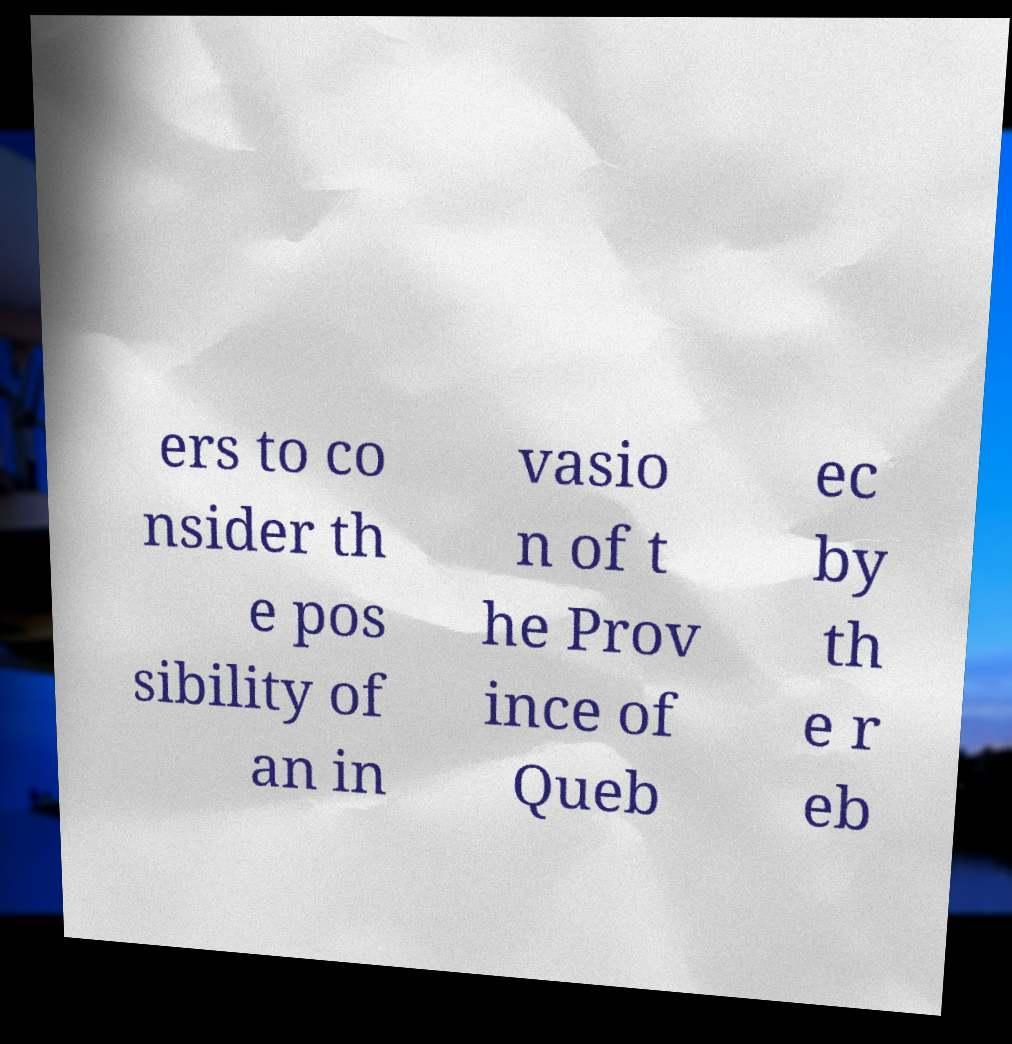I need the written content from this picture converted into text. Can you do that? ers to co nsider th e pos sibility of an in vasio n of t he Prov ince of Queb ec by th e r eb 